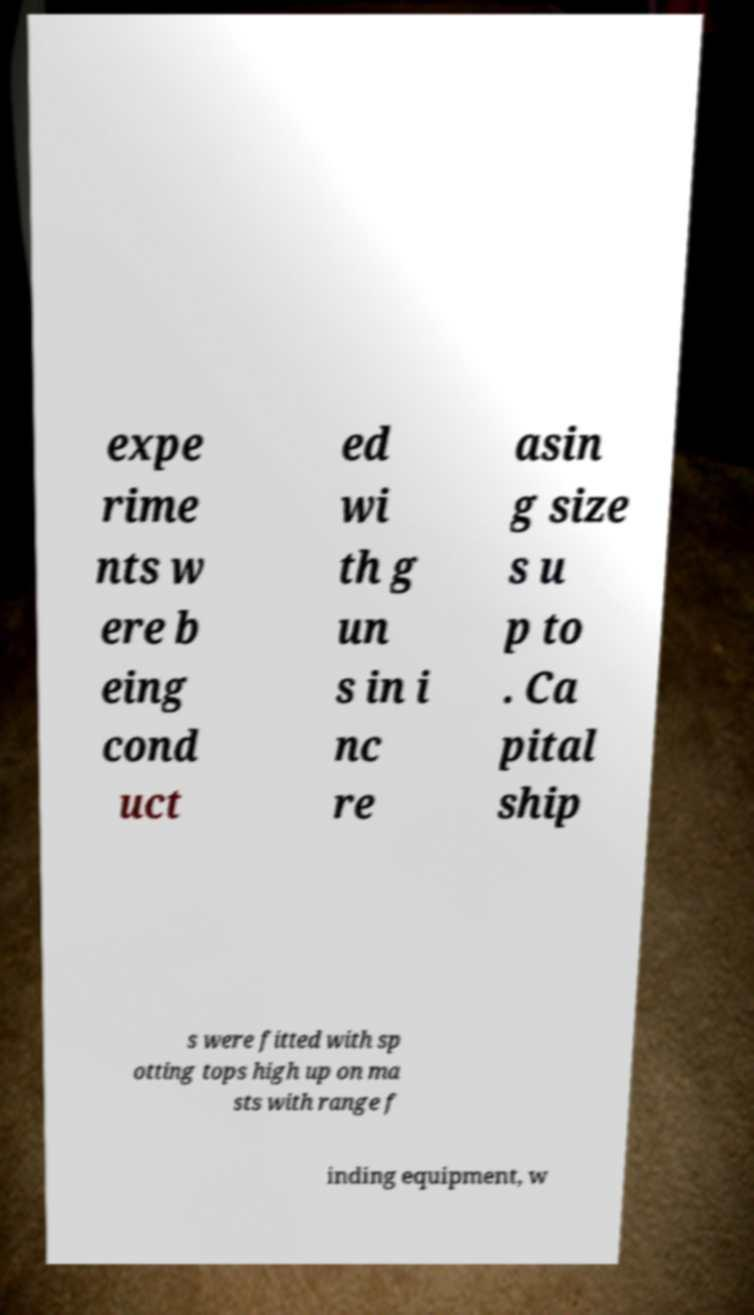Can you read and provide the text displayed in the image?This photo seems to have some interesting text. Can you extract and type it out for me? expe rime nts w ere b eing cond uct ed wi th g un s in i nc re asin g size s u p to . Ca pital ship s were fitted with sp otting tops high up on ma sts with range f inding equipment, w 